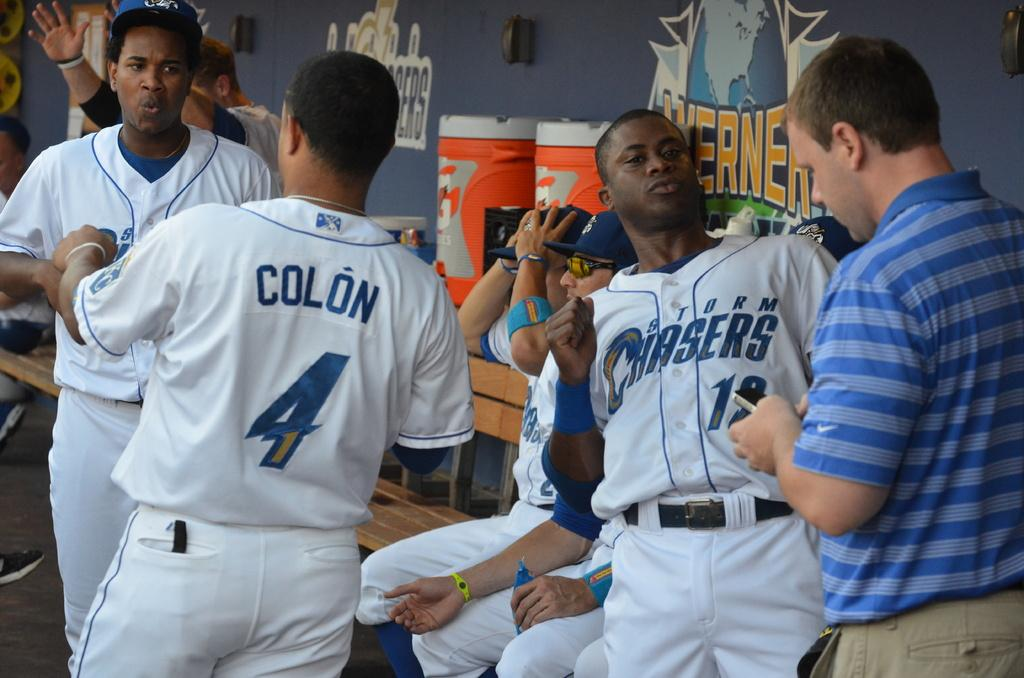<image>
Offer a succinct explanation of the picture presented. A group of baseball players  1 sitting down 4 standing up 2 of the standing  baseball players are talking to each other 